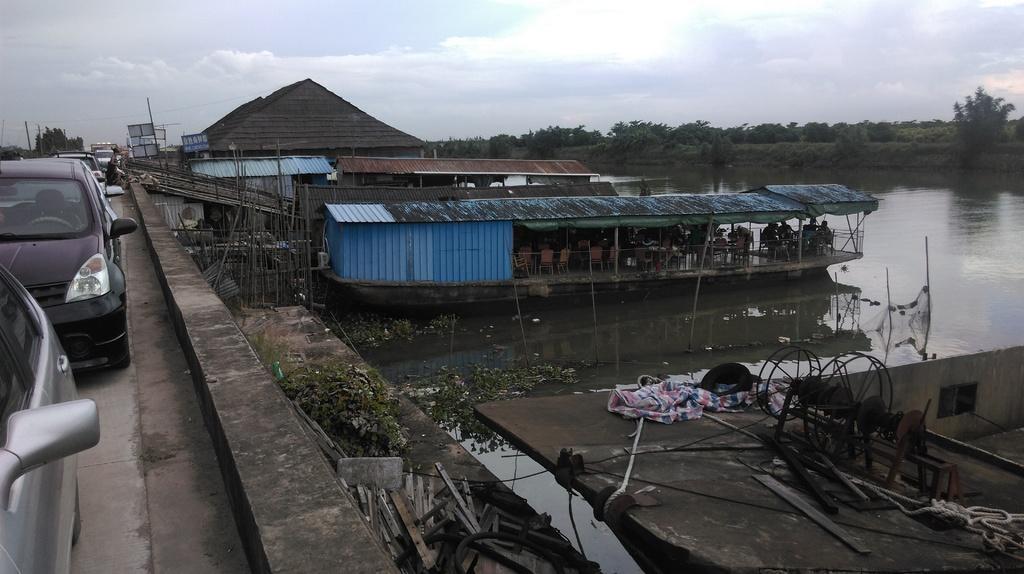Please provide a concise description of this image. On the left side there are vehicles. On the right side there is water. Also there are boats. In the boat there are chairs and many people. In the right bottom corner there is a surface with ropes, wooden pieces and many other things. In the background there are trees and sky. Also there are poles and name boards. 